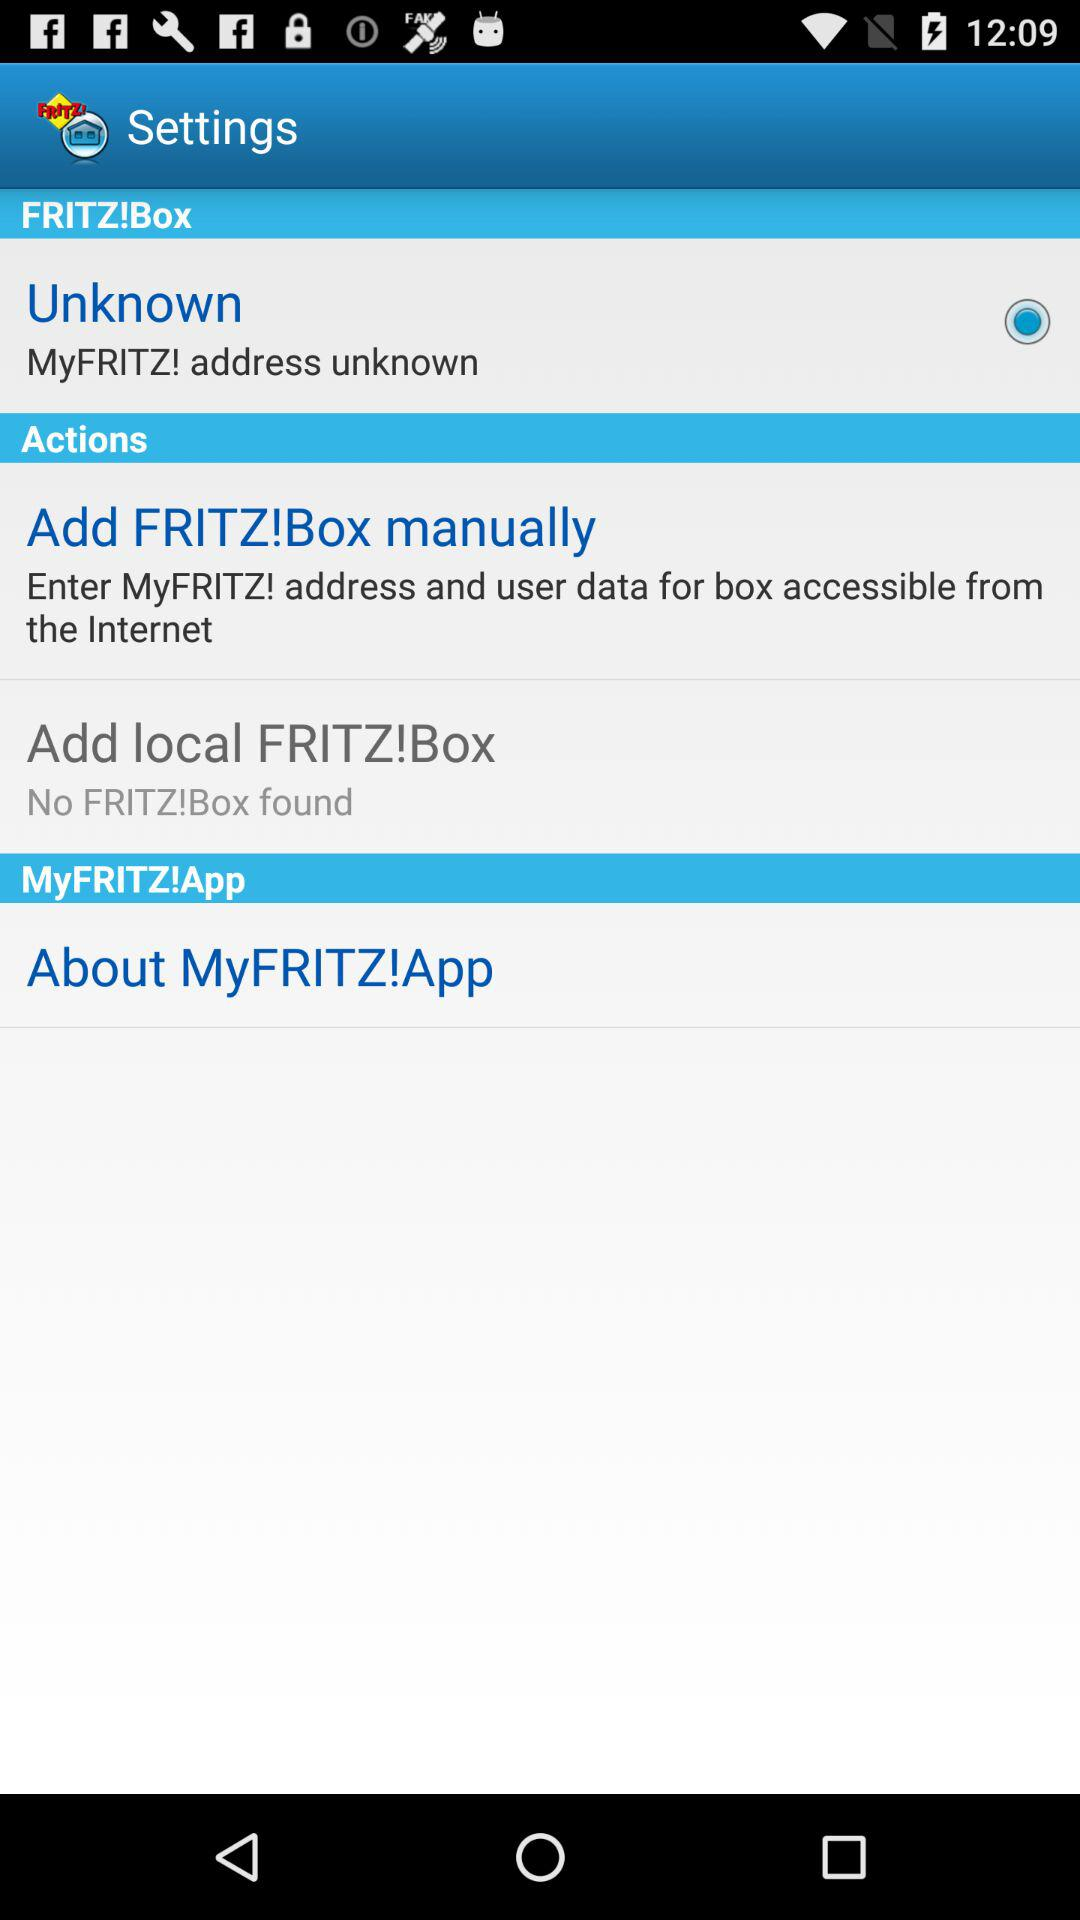What is the app name? The app name is "MyFRITZ!". 